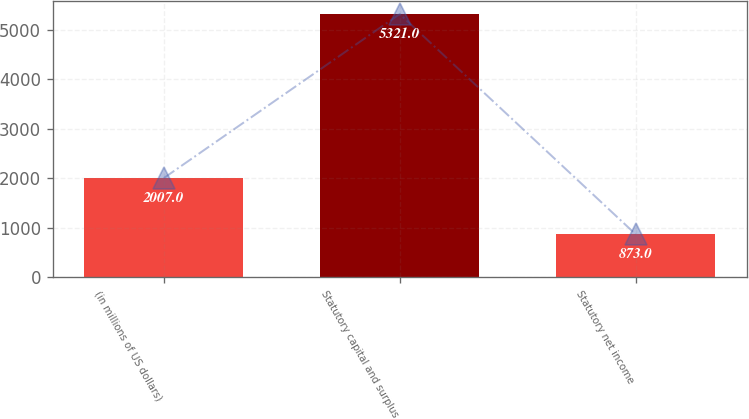Convert chart. <chart><loc_0><loc_0><loc_500><loc_500><bar_chart><fcel>(in millions of US dollars)<fcel>Statutory capital and surplus<fcel>Statutory net income<nl><fcel>2007<fcel>5321<fcel>873<nl></chart> 